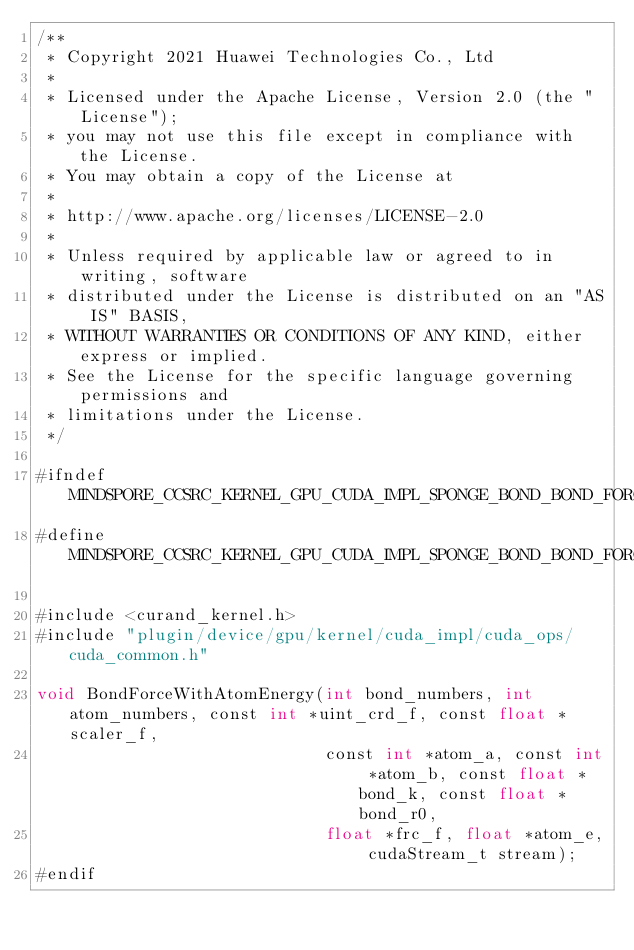Convert code to text. <code><loc_0><loc_0><loc_500><loc_500><_Cuda_>/**
 * Copyright 2021 Huawei Technologies Co., Ltd
 *
 * Licensed under the Apache License, Version 2.0 (the "License");
 * you may not use this file except in compliance with the License.
 * You may obtain a copy of the License at
 *
 * http://www.apache.org/licenses/LICENSE-2.0
 *
 * Unless required by applicable law or agreed to in writing, software
 * distributed under the License is distributed on an "AS IS" BASIS,
 * WITHOUT WARRANTIES OR CONDITIONS OF ANY KIND, either express or implied.
 * See the License for the specific language governing permissions and
 * limitations under the License.
 */

#ifndef MINDSPORE_CCSRC_KERNEL_GPU_CUDA_IMPL_SPONGE_BOND_BOND_FORCE_WITH_ATOM_ENERGY_IMPL_H_
#define MINDSPORE_CCSRC_KERNEL_GPU_CUDA_IMPL_SPONGE_BOND_BOND_FORCE_WITH_ATOM_ENERGY_IMPL_H_

#include <curand_kernel.h>
#include "plugin/device/gpu/kernel/cuda_impl/cuda_ops/cuda_common.h"

void BondForceWithAtomEnergy(int bond_numbers, int atom_numbers, const int *uint_crd_f, const float *scaler_f,
                             const int *atom_a, const int *atom_b, const float *bond_k, const float *bond_r0,
                             float *frc_f, float *atom_e, cudaStream_t stream);
#endif
</code> 